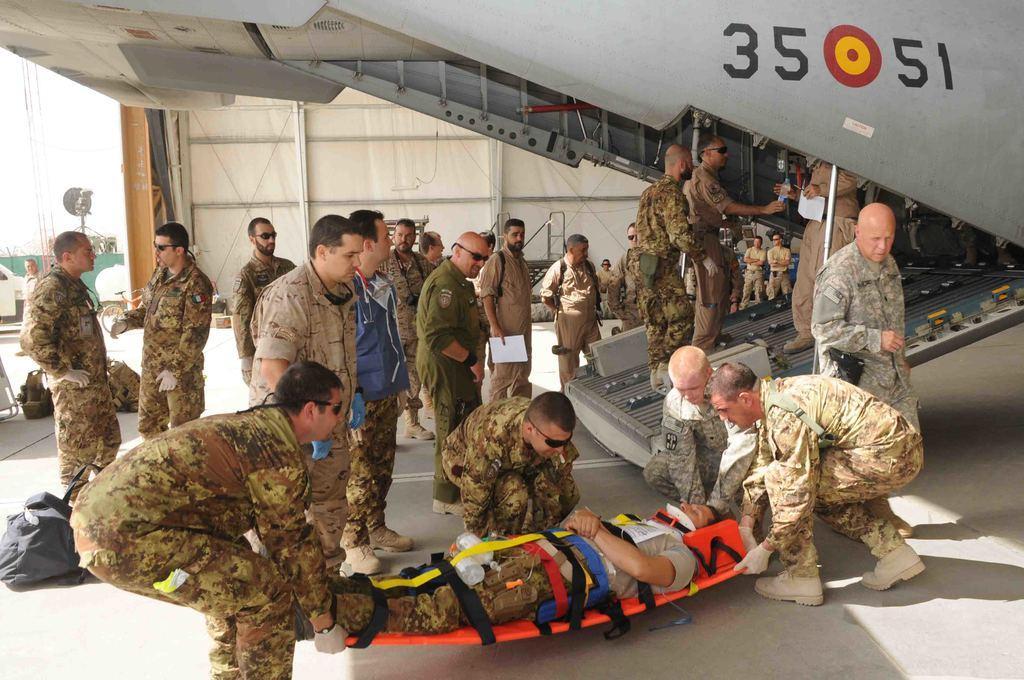How would you summarize this image in a sentence or two? In this picture there is a person lying on the stretcher and there are group of people holding the stretcher and there are group of people standing and there are three persons standing in the aircraft. At the back there is a staircase and wall. On the left side of the image there is a vehicle, pole and tree. At the bottom there are bags on the floor. 